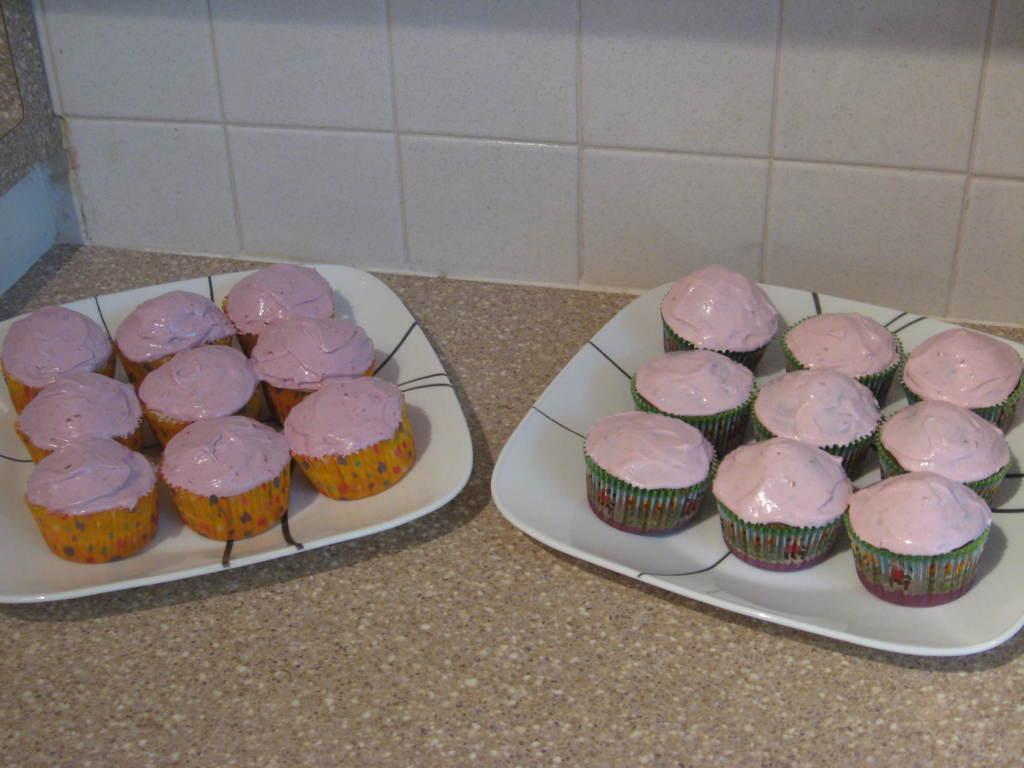In one or two sentences, can you explain what this image depicts? In the foreground of this image, on the floor there are pancakes on the platters. In the background, there is a wall. 